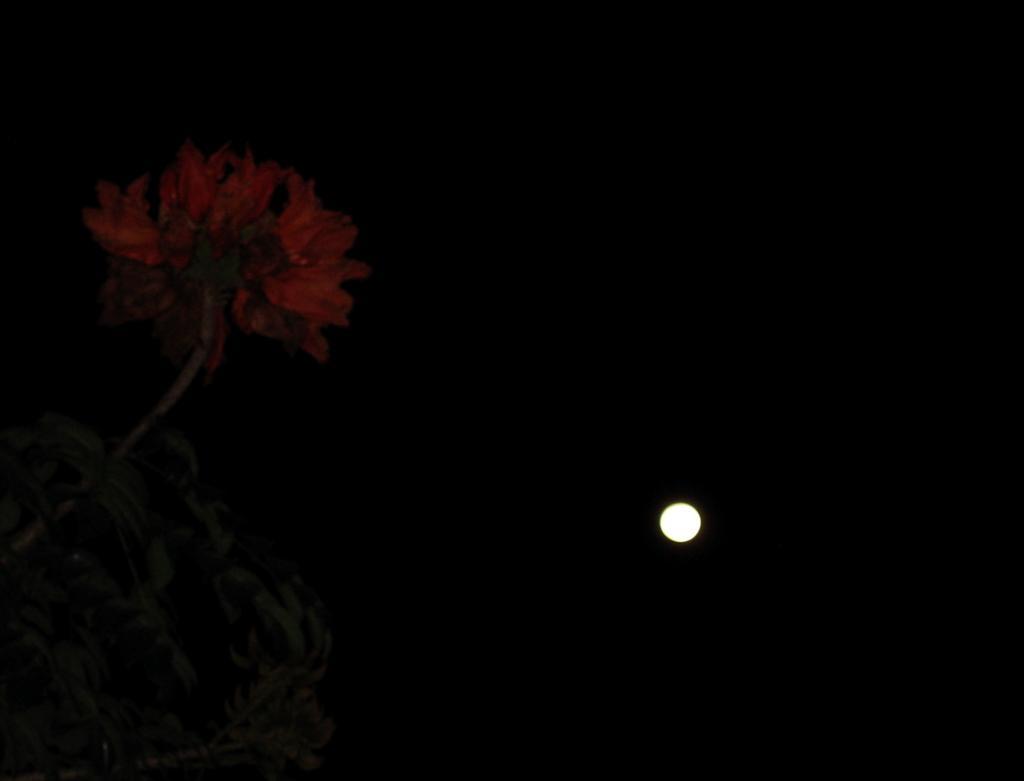How would you summarize this image in a sentence or two? In this picture there is a moon at the bottom side of the image and there is a flower on the left side of the image, it seems to be the picture is captured during night time. 